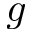Convert formula to latex. <formula><loc_0><loc_0><loc_500><loc_500>g</formula> 